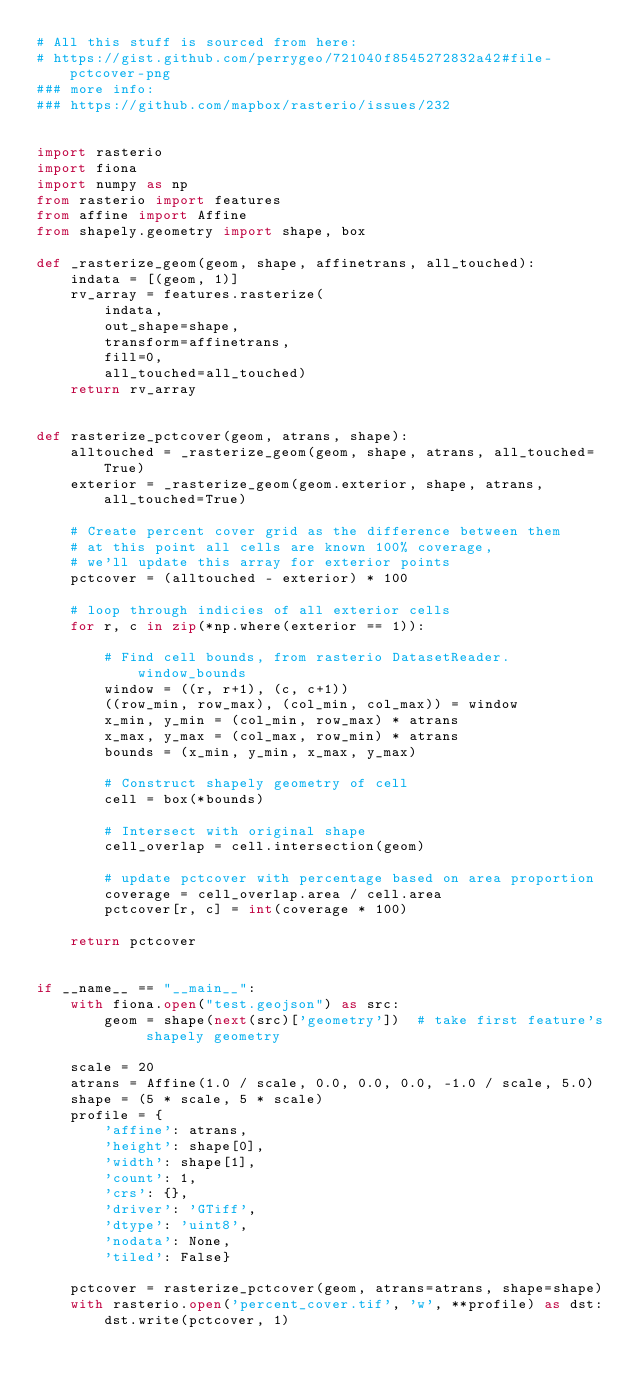Convert code to text. <code><loc_0><loc_0><loc_500><loc_500><_Python_># All this stuff is sourced from here:
# https://gist.github.com/perrygeo/721040f8545272832a42#file-pctcover-png
### more info:
### https://github.com/mapbox/rasterio/issues/232


import rasterio
import fiona
import numpy as np
from rasterio import features
from affine import Affine
from shapely.geometry import shape, box

def _rasterize_geom(geom, shape, affinetrans, all_touched):
    indata = [(geom, 1)]
    rv_array = features.rasterize(
        indata,
        out_shape=shape,
        transform=affinetrans,
        fill=0,
        all_touched=all_touched)
    return rv_array


def rasterize_pctcover(geom, atrans, shape):
    alltouched = _rasterize_geom(geom, shape, atrans, all_touched=True)
    exterior = _rasterize_geom(geom.exterior, shape, atrans, all_touched=True)

    # Create percent cover grid as the difference between them
    # at this point all cells are known 100% coverage,
    # we'll update this array for exterior points
    pctcover = (alltouched - exterior) * 100

    # loop through indicies of all exterior cells
    for r, c in zip(*np.where(exterior == 1)):

        # Find cell bounds, from rasterio DatasetReader.window_bounds
        window = ((r, r+1), (c, c+1))
        ((row_min, row_max), (col_min, col_max)) = window
        x_min, y_min = (col_min, row_max) * atrans
        x_max, y_max = (col_max, row_min) * atrans
        bounds = (x_min, y_min, x_max, y_max)

        # Construct shapely geometry of cell
        cell = box(*bounds)

        # Intersect with original shape
        cell_overlap = cell.intersection(geom)

        # update pctcover with percentage based on area proportion
        coverage = cell_overlap.area / cell.area
        pctcover[r, c] = int(coverage * 100)

    return pctcover


if __name__ == "__main__":
    with fiona.open("test.geojson") as src:
        geom = shape(next(src)['geometry'])  # take first feature's shapely geometry

    scale = 20
    atrans = Affine(1.0 / scale, 0.0, 0.0, 0.0, -1.0 / scale, 5.0)
    shape = (5 * scale, 5 * scale)
    profile = {
        'affine': atrans,
        'height': shape[0],
        'width': shape[1],
        'count': 1,
        'crs': {},
        'driver': 'GTiff',
        'dtype': 'uint8',
        'nodata': None,
        'tiled': False}

    pctcover = rasterize_pctcover(geom, atrans=atrans, shape=shape)
    with rasterio.open('percent_cover.tif', 'w', **profile) as dst:
        dst.write(pctcover, 1)</code> 